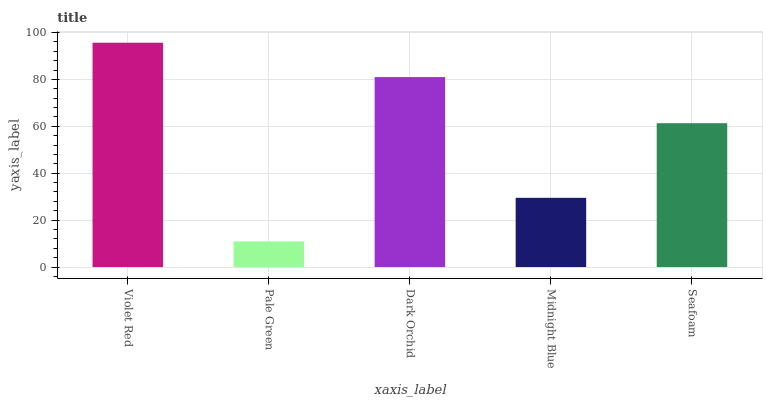Is Pale Green the minimum?
Answer yes or no. Yes. Is Violet Red the maximum?
Answer yes or no. Yes. Is Dark Orchid the minimum?
Answer yes or no. No. Is Dark Orchid the maximum?
Answer yes or no. No. Is Dark Orchid greater than Pale Green?
Answer yes or no. Yes. Is Pale Green less than Dark Orchid?
Answer yes or no. Yes. Is Pale Green greater than Dark Orchid?
Answer yes or no. No. Is Dark Orchid less than Pale Green?
Answer yes or no. No. Is Seafoam the high median?
Answer yes or no. Yes. Is Seafoam the low median?
Answer yes or no. Yes. Is Dark Orchid the high median?
Answer yes or no. No. Is Violet Red the low median?
Answer yes or no. No. 